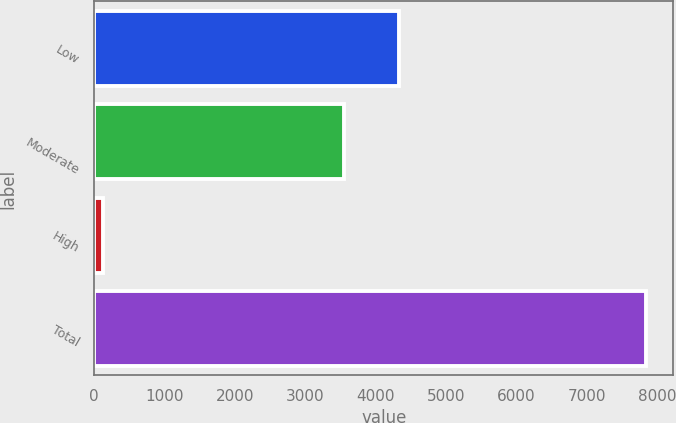Convert chart to OTSL. <chart><loc_0><loc_0><loc_500><loc_500><bar_chart><fcel>Low<fcel>Moderate<fcel>High<fcel>Total<nl><fcel>4327.2<fcel>3556<fcel>132<fcel>7844<nl></chart> 